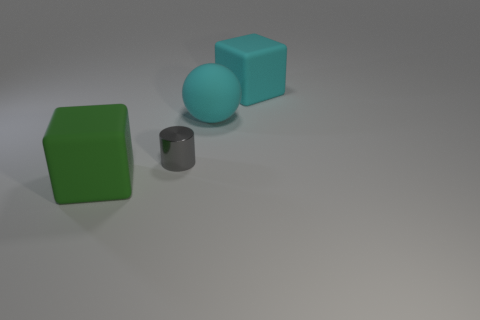Add 1 big blue metallic objects. How many objects exist? 5 Subtract all spheres. How many objects are left? 3 Add 4 green matte things. How many green matte things exist? 5 Subtract 1 cyan balls. How many objects are left? 3 Subtract all large blocks. Subtract all matte blocks. How many objects are left? 0 Add 4 cyan things. How many cyan things are left? 6 